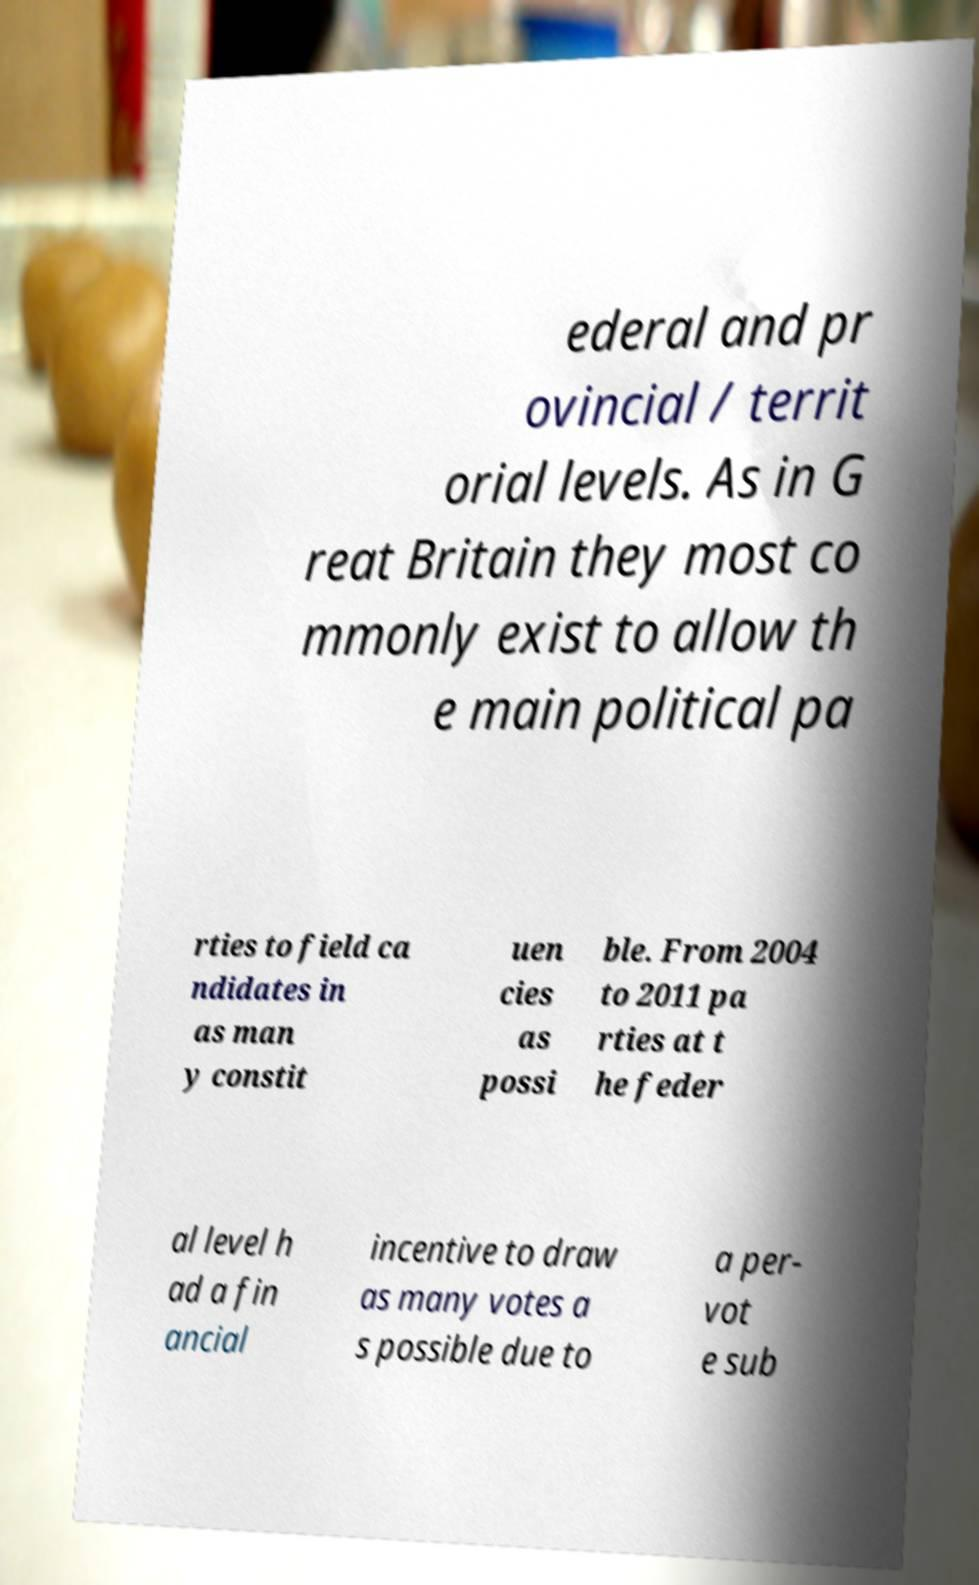For documentation purposes, I need the text within this image transcribed. Could you provide that? ederal and pr ovincial / territ orial levels. As in G reat Britain they most co mmonly exist to allow th e main political pa rties to field ca ndidates in as man y constit uen cies as possi ble. From 2004 to 2011 pa rties at t he feder al level h ad a fin ancial incentive to draw as many votes a s possible due to a per- vot e sub 